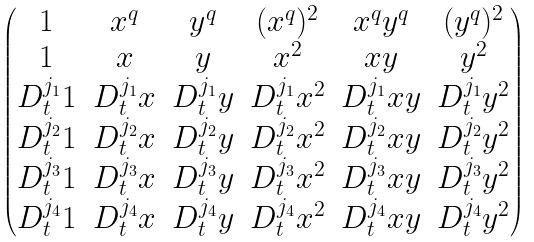Convert formula to latex. <formula><loc_0><loc_0><loc_500><loc_500>\begin{pmatrix} 1 & x ^ { q } & y ^ { q } & ( x ^ { q } ) ^ { 2 } & x ^ { q } y ^ { q } & ( y ^ { q } ) ^ { 2 } \\ 1 & x & y & x ^ { 2 } & x y & y ^ { 2 } \\ D ^ { j _ { 1 } } _ { t } 1 & D ^ { j _ { 1 } } _ { t } x & D ^ { j _ { 1 } } _ { t } y & D ^ { j _ { 1 } } _ { t } x ^ { 2 } & D ^ { j _ { 1 } } _ { t } x y & D ^ { j _ { 1 } } _ { t } y ^ { 2 } \\ D ^ { j _ { 2 } } _ { t } 1 & D ^ { j _ { 2 } } _ { t } x & D ^ { j _ { 2 } } _ { t } y & D ^ { j _ { 2 } } _ { t } x ^ { 2 } & D ^ { j _ { 2 } } _ { t } x y & D ^ { j _ { 2 } } _ { t } y ^ { 2 } \\ D ^ { j _ { 3 } } _ { t } 1 & D ^ { j _ { 3 } } _ { t } x & D ^ { j _ { 3 } } _ { t } y & D ^ { j _ { 3 } } _ { t } x ^ { 2 } & D ^ { j _ { 3 } } _ { t } x y & D ^ { j _ { 3 } } _ { t } y ^ { 2 } \\ D ^ { j _ { 4 } } _ { t } 1 & D ^ { j _ { 4 } } _ { t } x & D ^ { j _ { 4 } } _ { t } y & D ^ { j _ { 4 } } _ { t } x ^ { 2 } & D ^ { j _ { 4 } } _ { t } x y & D ^ { j _ { 4 } } _ { t } y ^ { 2 } \end{pmatrix}</formula> 